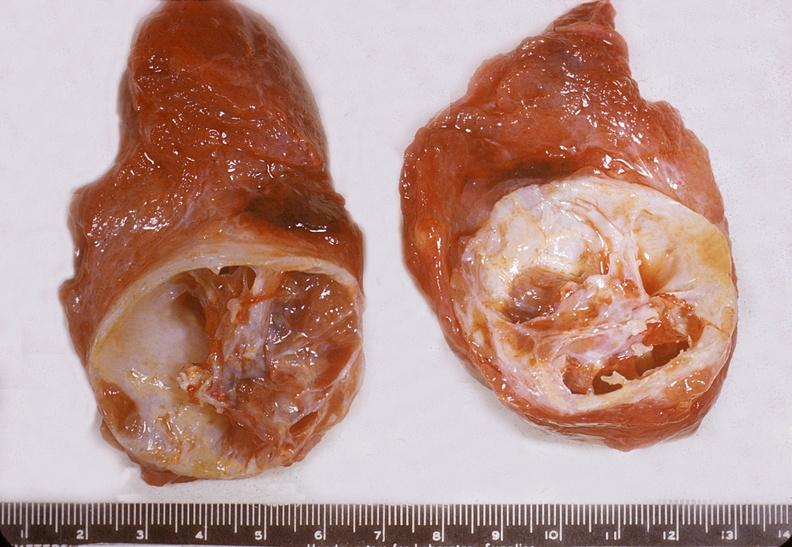does lower chest and abdomen anterior show thyroid, nodular colloid goiter with cystic degeneration?
Answer the question using a single word or phrase. No 